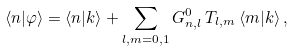<formula> <loc_0><loc_0><loc_500><loc_500>\langle n | \varphi \rangle = \langle n | k \rangle + \sum _ { l , m = 0 , 1 } G ^ { 0 } _ { n , l } \, T _ { l , m } \, \langle m | k \rangle \, ,</formula> 